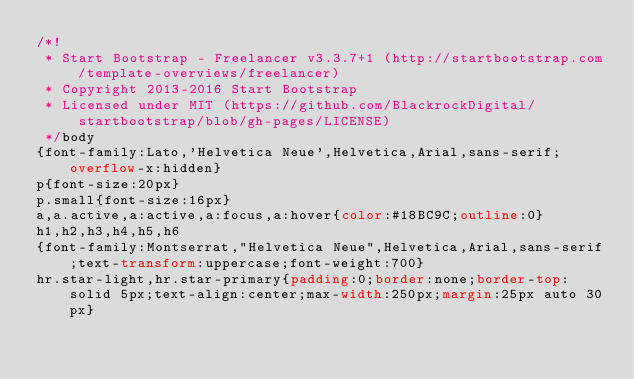Convert code to text. <code><loc_0><loc_0><loc_500><loc_500><_CSS_>/*!
 * Start Bootstrap - Freelancer v3.3.7+1 (http://startbootstrap.com/template-overviews/freelancer)
 * Copyright 2013-2016 Start Bootstrap
 * Licensed under MIT (https://github.com/BlackrockDigital/startbootstrap/blob/gh-pages/LICENSE)
 */body
{font-family:Lato,'Helvetica Neue',Helvetica,Arial,sans-serif;overflow-x:hidden}
p{font-size:20px}
p.small{font-size:16px}
a,a.active,a:active,a:focus,a:hover{color:#18BC9C;outline:0}
h1,h2,h3,h4,h5,h6
{font-family:Montserrat,"Helvetica Neue",Helvetica,Arial,sans-serif;text-transform:uppercase;font-weight:700}
hr.star-light,hr.star-primary{padding:0;border:none;border-top:solid 5px;text-align:center;max-width:250px;margin:25px auto 30px}</code> 